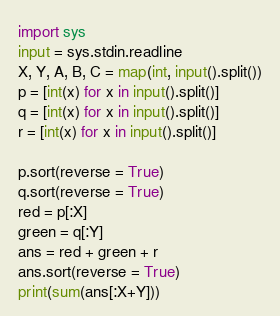<code> <loc_0><loc_0><loc_500><loc_500><_Python_>import sys
input = sys.stdin.readline
X, Y, A, B, C = map(int, input().split())
p = [int(x) for x in input().split()]
q = [int(x) for x in input().split()]
r = [int(x) for x in input().split()]

p.sort(reverse = True)
q.sort(reverse = True)
red = p[:X]
green = q[:Y]
ans = red + green + r
ans.sort(reverse = True)
print(sum(ans[:X+Y]))
</code> 